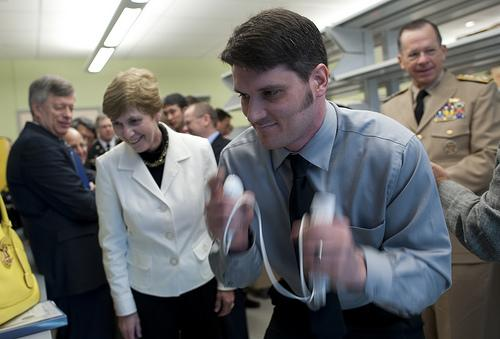Point out an object in the image that has a yellow color. There is a yellow purse on a table in the image. What type of uniform is the old man wearing? The old man is wearing a military uniform. What is the man doing with the game controllers? The man is holding the game controllers and possibly playing a game. Tell me the color of the woman's jacket in the image and what she is doing. The woman is wearing a white jacket and smiling. Mention an accessory worn by someone in the image. A gold chain necklace is worn by someone in the image. How many people are looking at something in the image? There are multiple people looking at something in the image. Identify the color of the shirt worn by the man holding the controllers. The man holding the controllers is wearing a blue shirt. What is the specific type of controllers the man is holding? The man is holding white Wii game controllers. State the color of the handbag visible in the image. The handbag in the image is yellow. 